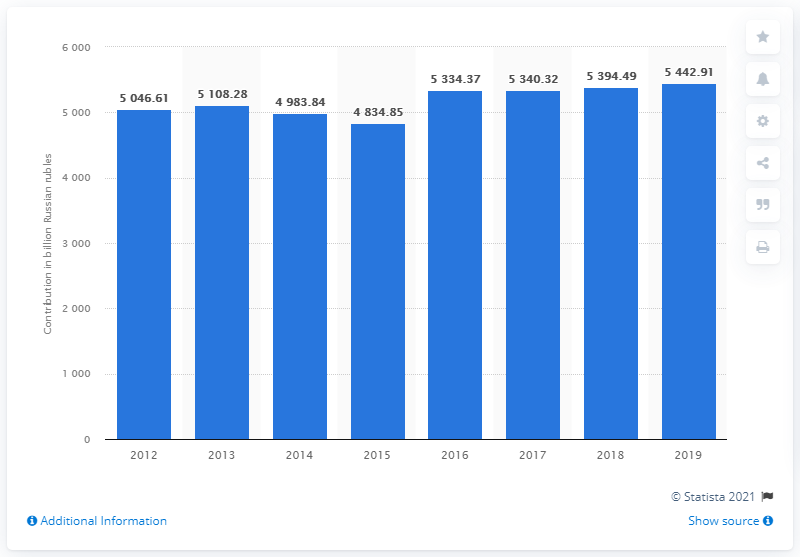Mention a couple of crucial points in this snapshot. In 2019, the travel and tourism industry contributed 54,42.91 Russian rubles to Russia's gross domestic product. 